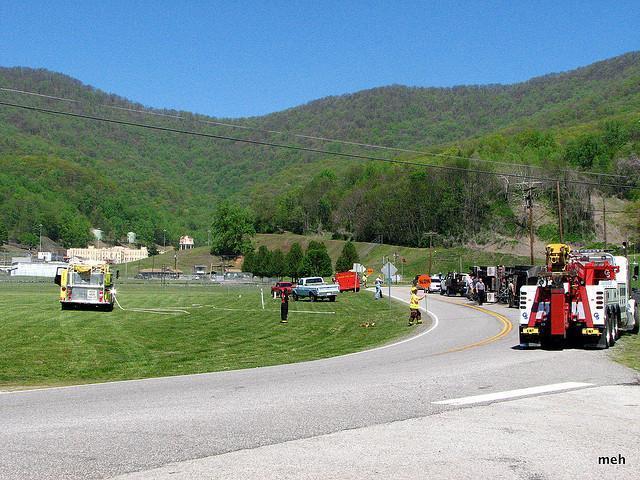How many fire trucks are in this photo?
Give a very brief answer. 1. How many trucks are in the picture?
Give a very brief answer. 2. How many signs have bus icon on a pole?
Give a very brief answer. 0. 